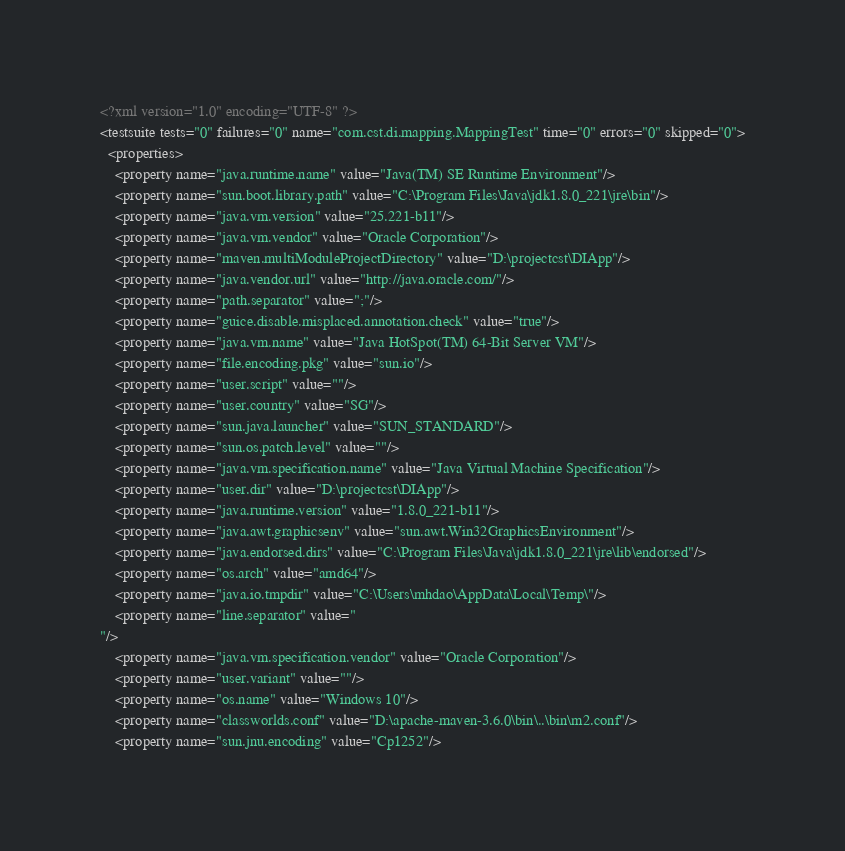<code> <loc_0><loc_0><loc_500><loc_500><_XML_><?xml version="1.0" encoding="UTF-8" ?>
<testsuite tests="0" failures="0" name="com.cst.di.mapping.MappingTest" time="0" errors="0" skipped="0">
  <properties>
    <property name="java.runtime.name" value="Java(TM) SE Runtime Environment"/>
    <property name="sun.boot.library.path" value="C:\Program Files\Java\jdk1.8.0_221\jre\bin"/>
    <property name="java.vm.version" value="25.221-b11"/>
    <property name="java.vm.vendor" value="Oracle Corporation"/>
    <property name="maven.multiModuleProjectDirectory" value="D:\projectcst\DIApp"/>
    <property name="java.vendor.url" value="http://java.oracle.com/"/>
    <property name="path.separator" value=";"/>
    <property name="guice.disable.misplaced.annotation.check" value="true"/>
    <property name="java.vm.name" value="Java HotSpot(TM) 64-Bit Server VM"/>
    <property name="file.encoding.pkg" value="sun.io"/>
    <property name="user.script" value=""/>
    <property name="user.country" value="SG"/>
    <property name="sun.java.launcher" value="SUN_STANDARD"/>
    <property name="sun.os.patch.level" value=""/>
    <property name="java.vm.specification.name" value="Java Virtual Machine Specification"/>
    <property name="user.dir" value="D:\projectcst\DIApp"/>
    <property name="java.runtime.version" value="1.8.0_221-b11"/>
    <property name="java.awt.graphicsenv" value="sun.awt.Win32GraphicsEnvironment"/>
    <property name="java.endorsed.dirs" value="C:\Program Files\Java\jdk1.8.0_221\jre\lib\endorsed"/>
    <property name="os.arch" value="amd64"/>
    <property name="java.io.tmpdir" value="C:\Users\mhdao\AppData\Local\Temp\"/>
    <property name="line.separator" value="
"/>
    <property name="java.vm.specification.vendor" value="Oracle Corporation"/>
    <property name="user.variant" value=""/>
    <property name="os.name" value="Windows 10"/>
    <property name="classworlds.conf" value="D:\apache-maven-3.6.0\bin\..\bin\m2.conf"/>
    <property name="sun.jnu.encoding" value="Cp1252"/></code> 